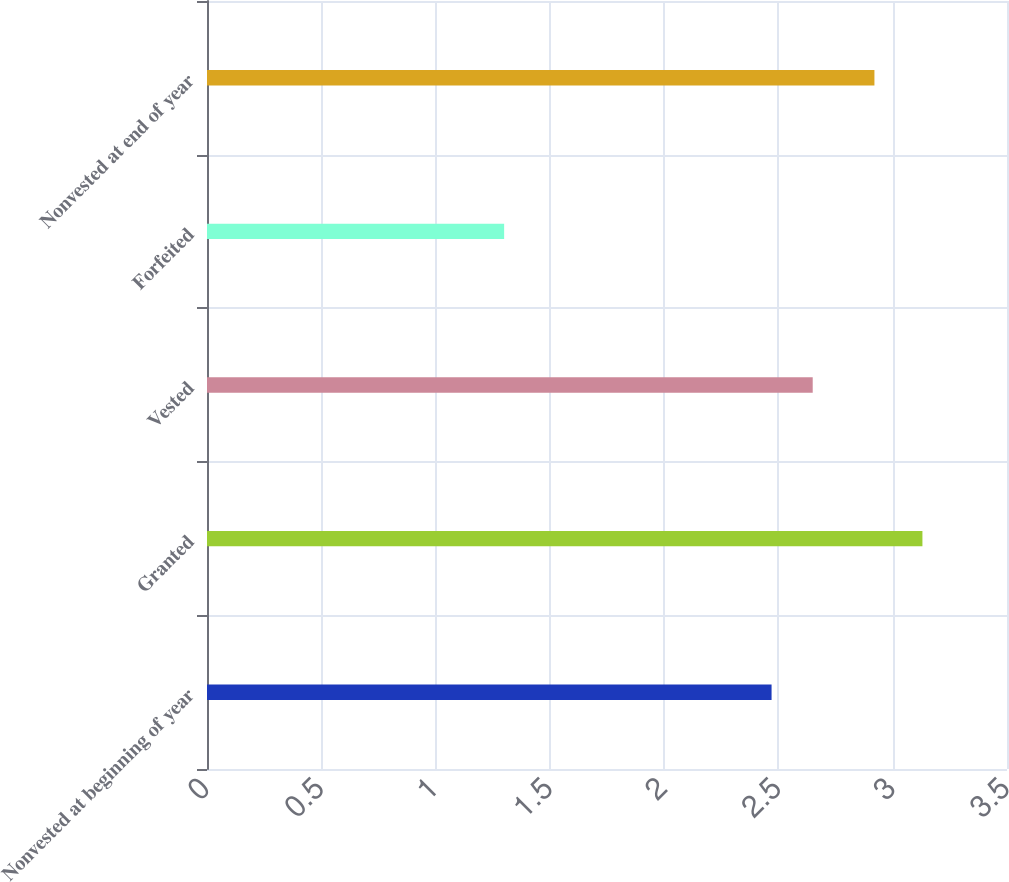<chart> <loc_0><loc_0><loc_500><loc_500><bar_chart><fcel>Nonvested at beginning of year<fcel>Granted<fcel>Vested<fcel>Forfeited<fcel>Nonvested at end of year<nl><fcel>2.47<fcel>3.13<fcel>2.65<fcel>1.3<fcel>2.92<nl></chart> 